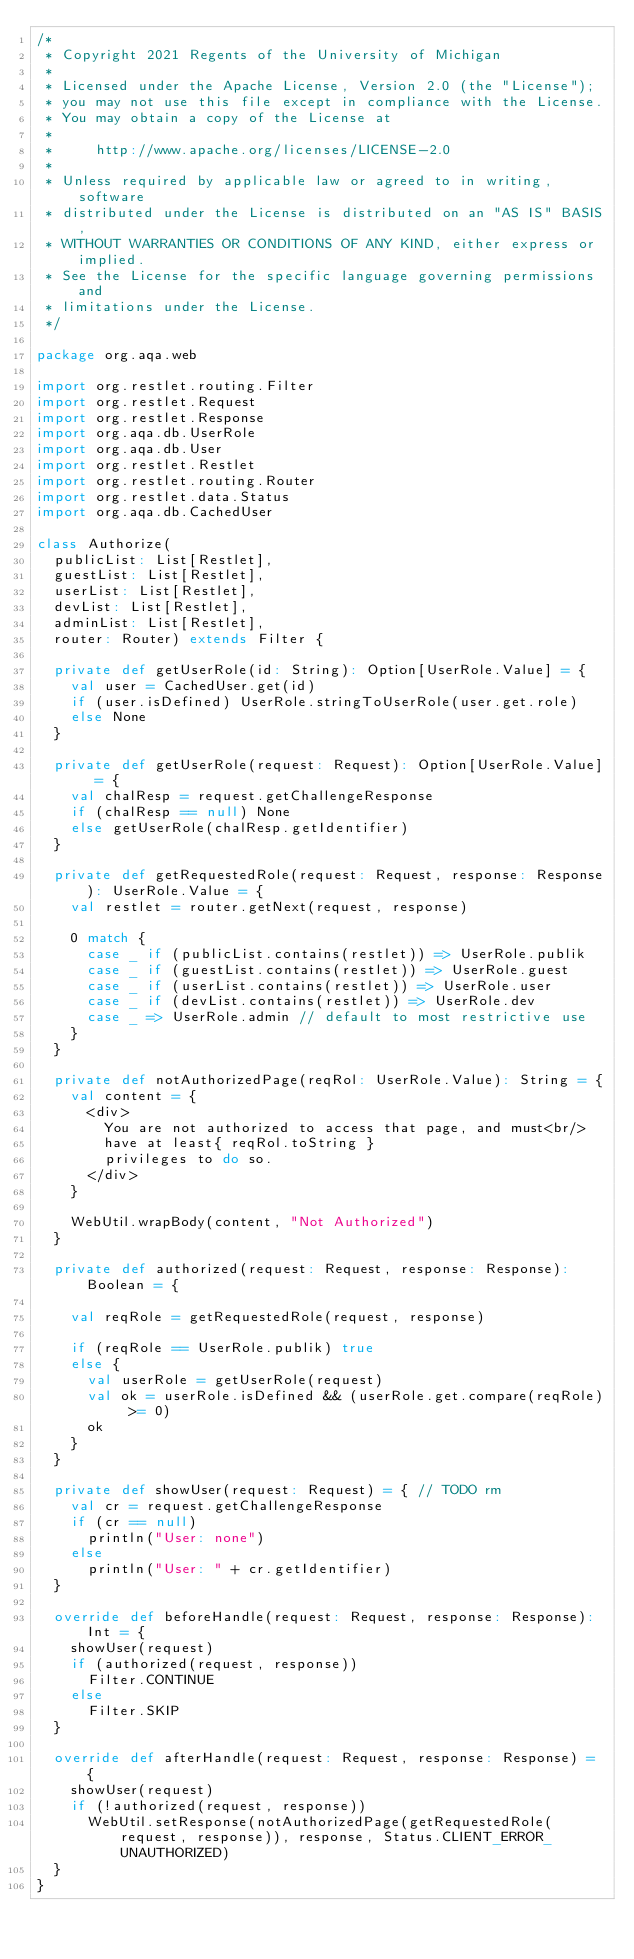<code> <loc_0><loc_0><loc_500><loc_500><_Scala_>/*
 * Copyright 2021 Regents of the University of Michigan
 *
 * Licensed under the Apache License, Version 2.0 (the "License");
 * you may not use this file except in compliance with the License.
 * You may obtain a copy of the License at
 *
 *     http://www.apache.org/licenses/LICENSE-2.0
 *
 * Unless required by applicable law or agreed to in writing, software
 * distributed under the License is distributed on an "AS IS" BASIS,
 * WITHOUT WARRANTIES OR CONDITIONS OF ANY KIND, either express or implied.
 * See the License for the specific language governing permissions and
 * limitations under the License.
 */

package org.aqa.web

import org.restlet.routing.Filter
import org.restlet.Request
import org.restlet.Response
import org.aqa.db.UserRole
import org.aqa.db.User
import org.restlet.Restlet
import org.restlet.routing.Router
import org.restlet.data.Status
import org.aqa.db.CachedUser

class Authorize(
  publicList: List[Restlet],
  guestList: List[Restlet],
  userList: List[Restlet],
  devList: List[Restlet],
  adminList: List[Restlet],
  router: Router) extends Filter {

  private def getUserRole(id: String): Option[UserRole.Value] = {
    val user = CachedUser.get(id)
    if (user.isDefined) UserRole.stringToUserRole(user.get.role)
    else None
  }

  private def getUserRole(request: Request): Option[UserRole.Value] = {
    val chalResp = request.getChallengeResponse
    if (chalResp == null) None
    else getUserRole(chalResp.getIdentifier)
  }

  private def getRequestedRole(request: Request, response: Response): UserRole.Value = {
    val restlet = router.getNext(request, response)

    0 match {
      case _ if (publicList.contains(restlet)) => UserRole.publik
      case _ if (guestList.contains(restlet)) => UserRole.guest
      case _ if (userList.contains(restlet)) => UserRole.user
      case _ if (devList.contains(restlet)) => UserRole.dev
      case _ => UserRole.admin // default to most restrictive use
    }
  }

  private def notAuthorizedPage(reqRol: UserRole.Value): String = {
    val content = {
      <div>
        You are not authorized to access that page, and must<br/>
        have at least{ reqRol.toString }
        privileges to do so.
      </div>
    }

    WebUtil.wrapBody(content, "Not Authorized")
  }

  private def authorized(request: Request, response: Response): Boolean = {

    val reqRole = getRequestedRole(request, response)

    if (reqRole == UserRole.publik) true
    else {
      val userRole = getUserRole(request)
      val ok = userRole.isDefined && (userRole.get.compare(reqRole) >= 0)
      ok
    }
  }

  private def showUser(request: Request) = { // TODO rm
    val cr = request.getChallengeResponse
    if (cr == null)
      println("User: none")
    else
      println("User: " + cr.getIdentifier)
  }

  override def beforeHandle(request: Request, response: Response): Int = {
    showUser(request)
    if (authorized(request, response))
      Filter.CONTINUE
    else
      Filter.SKIP
  }

  override def afterHandle(request: Request, response: Response) = {
    showUser(request)
    if (!authorized(request, response))
      WebUtil.setResponse(notAuthorizedPage(getRequestedRole(request, response)), response, Status.CLIENT_ERROR_UNAUTHORIZED)
  }
}
</code> 